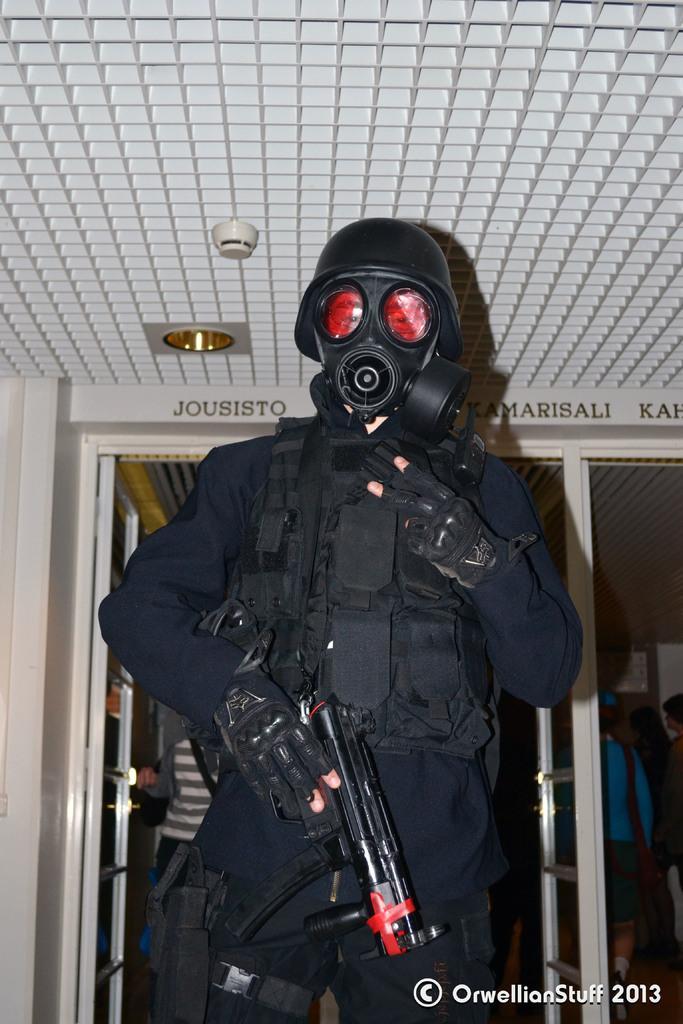In one or two sentences, can you explain what this image depicts? In this picture I can see a person with a costume, there is a building, there are few people standing and there is a watermark on the image. 